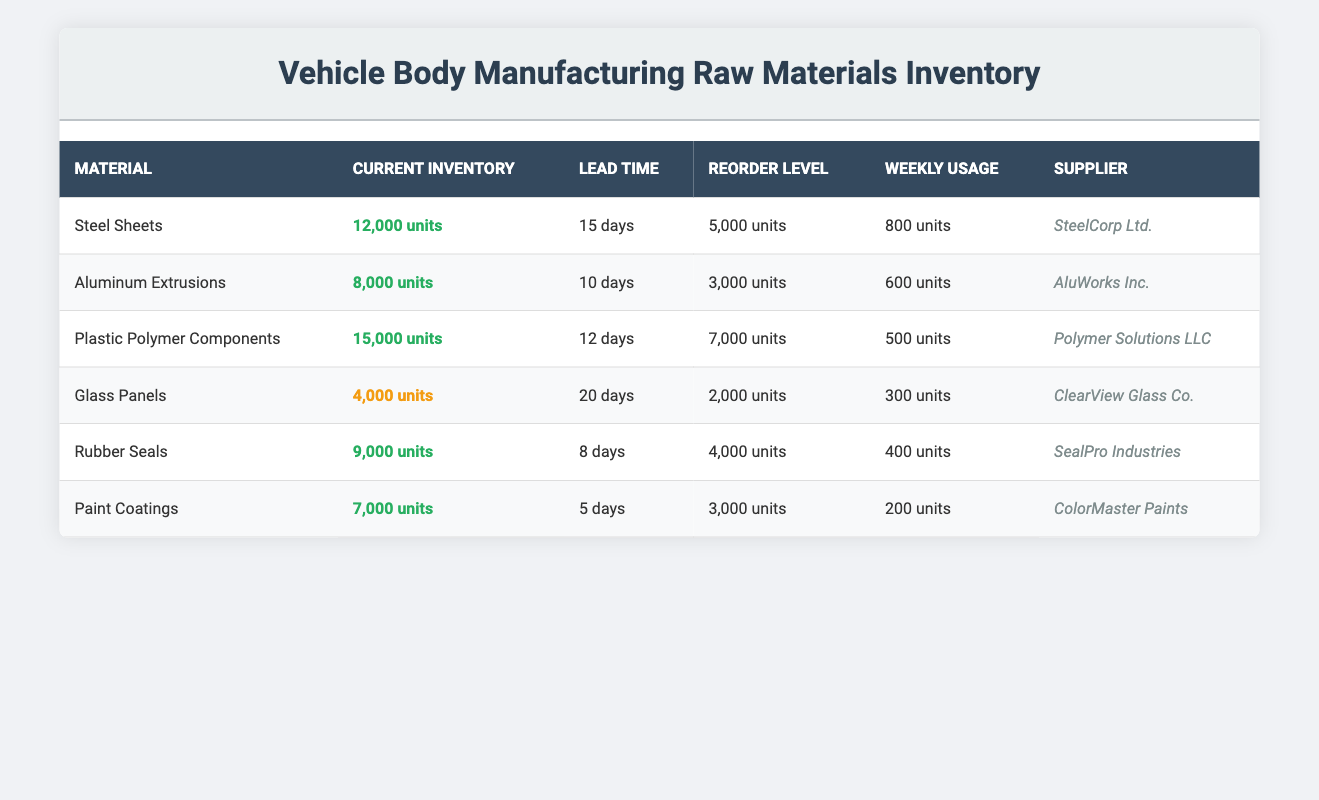What is the current inventory of Plastic Polymer Components? Referring to the table, the current inventory for Plastic Polymer Components is clearly stated as 15,000 units.
Answer: 15,000 units Which material has the highest current inventory? By checking the current inventory values listed, Plastic Polymer Components with 15,000 units surpasses all other materials.
Answer: Plastic Polymer Components What is the average lead time for all materials listed? To find the average lead time, first add the lead times: 15 + 10 + 12 + 20 + 8 + 5 = 70 days. Then divide by the number of materials (6), which results in 70/6 = 11.67, rounded to two decimal places gives 11.67 days.
Answer: 11.67 days Is the current inventory of Glass Panels below the reorder level? The current inventory of Glass Panels is 4,000 units, and the reorder level is 2,000 units. Since 4,000 is greater than 2,000, the statement is false.
Answer: No What is the total current inventory of all materials combined? To find the total inventory combine all the current inventory values: 12,000 + 8,000 + 15,000 + 4,000 + 9,000 + 7,000 = 55,000 units.
Answer: 55,000 units Which materials have an average lead time of 12 days or longer? From the table, the materials with a lead time of 12 days or more are Steel Sheets (15), Plastic Polymer Components (12), and Glass Panels (20).
Answer: Steel Sheets, Plastic Polymer Components, Glass Panels Are the Rubber Seals classified as low inventory status? The current inventory of Rubber Seals is 9,000 units, which is above the reorder level of 4,000 units, hence it is not classified as low inventory.
Answer: No Calculate the weekly usage of Steel Sheets and Rubber Seals combined. The weekly usage for Steel Sheets is 800 units and for Rubber Seals is 400 units. Summing these gives 800 + 400 = 1,200 units.
Answer: 1,200 units 